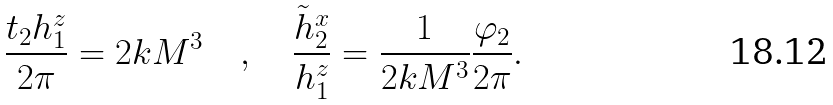Convert formula to latex. <formula><loc_0><loc_0><loc_500><loc_500>\frac { t _ { 2 } h _ { 1 } ^ { z } } { 2 \pi } = 2 k M ^ { 3 } \quad , \quad \frac { \tilde { h } _ { 2 } ^ { x } } { h _ { 1 } ^ { z } } = \frac { 1 } { 2 k M ^ { 3 } } \frac { \varphi _ { 2 } } { 2 \pi } .</formula> 